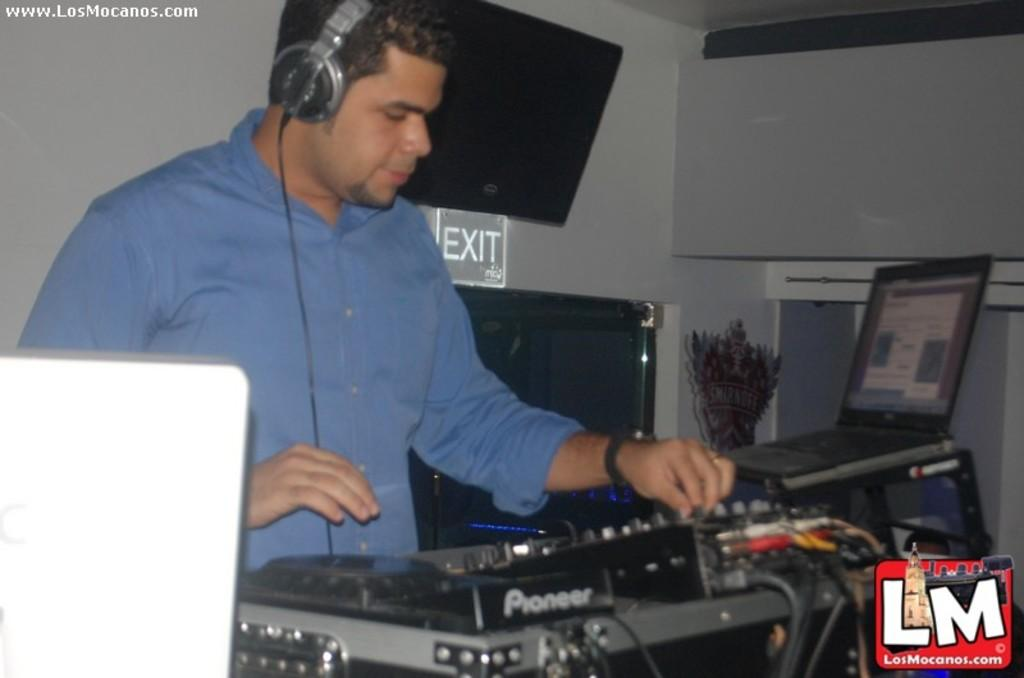<image>
Present a compact description of the photo's key features. a man with the words LM in the bottom right 